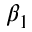<formula> <loc_0><loc_0><loc_500><loc_500>\beta _ { 1 }</formula> 